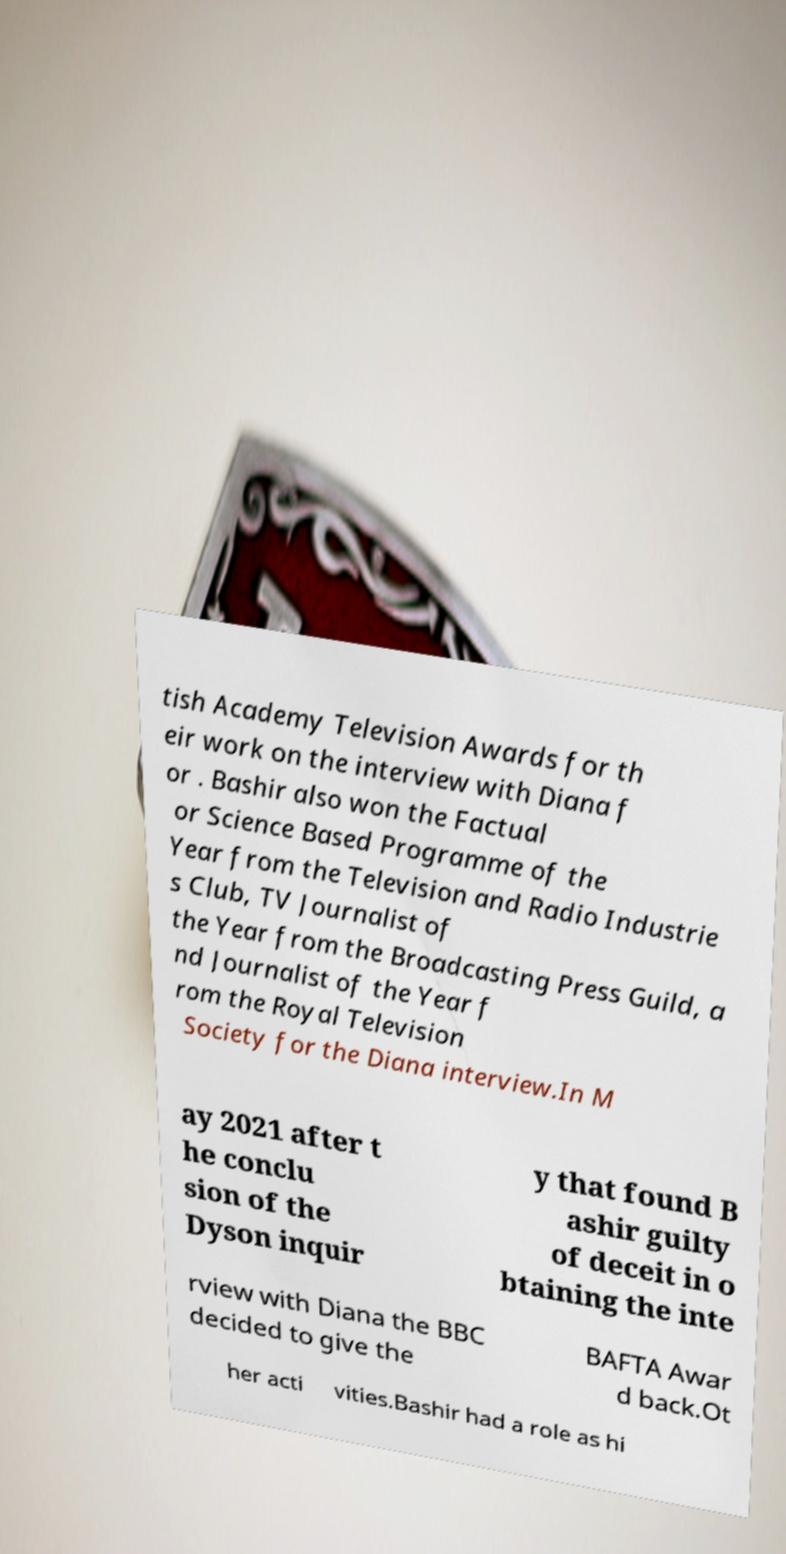Please identify and transcribe the text found in this image. tish Academy Television Awards for th eir work on the interview with Diana f or . Bashir also won the Factual or Science Based Programme of the Year from the Television and Radio Industrie s Club, TV Journalist of the Year from the Broadcasting Press Guild, a nd Journalist of the Year f rom the Royal Television Society for the Diana interview.In M ay 2021 after t he conclu sion of the Dyson inquir y that found B ashir guilty of deceit in o btaining the inte rview with Diana the BBC decided to give the BAFTA Awar d back.Ot her acti vities.Bashir had a role as hi 